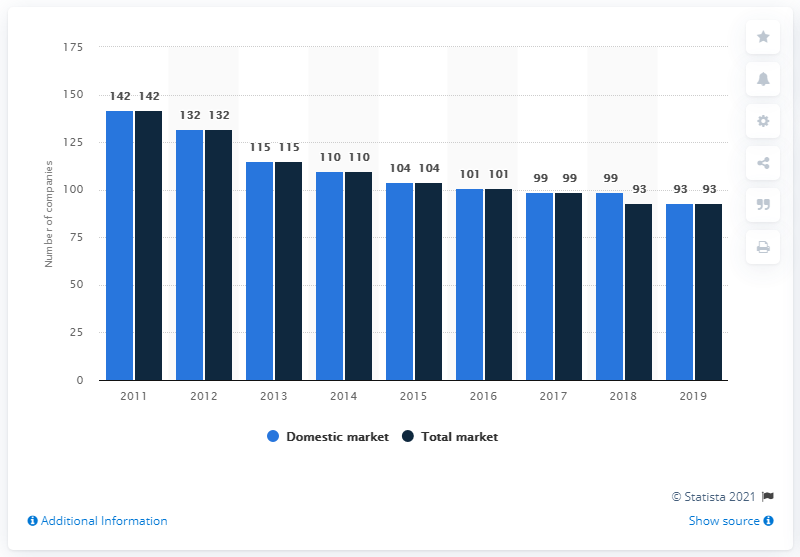Identify some key points in this picture. In 2011, there were 142 companies present on the Danish domestic insurance market. In approximately 8 years, the number of companies in the domestic market will be equal to the number of companies in the total market. At the end of 2019, there were 93 insurance companies present on the Danish domestic insurance market. The average of the total markets in 2016, 2017, and 2018 is 97.67. 